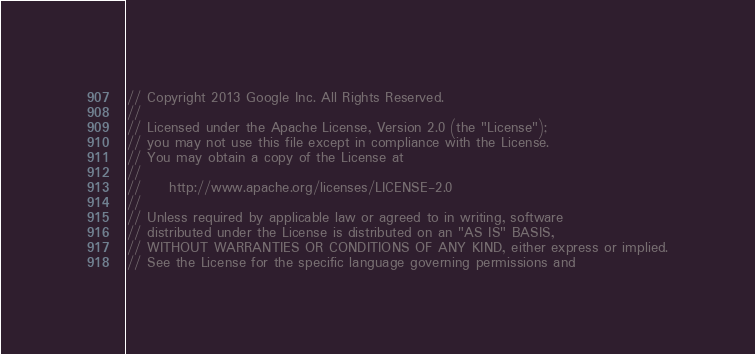<code> <loc_0><loc_0><loc_500><loc_500><_C++_>// Copyright 2013 Google Inc. All Rights Reserved.
//
// Licensed under the Apache License, Version 2.0 (the "License");
// you may not use this file except in compliance with the License.
// You may obtain a copy of the License at
//
//     http://www.apache.org/licenses/LICENSE-2.0
//
// Unless required by applicable law or agreed to in writing, software
// distributed under the License is distributed on an "AS IS" BASIS,
// WITHOUT WARRANTIES OR CONDITIONS OF ANY KIND, either express or implied.
// See the License for the specific language governing permissions and</code> 